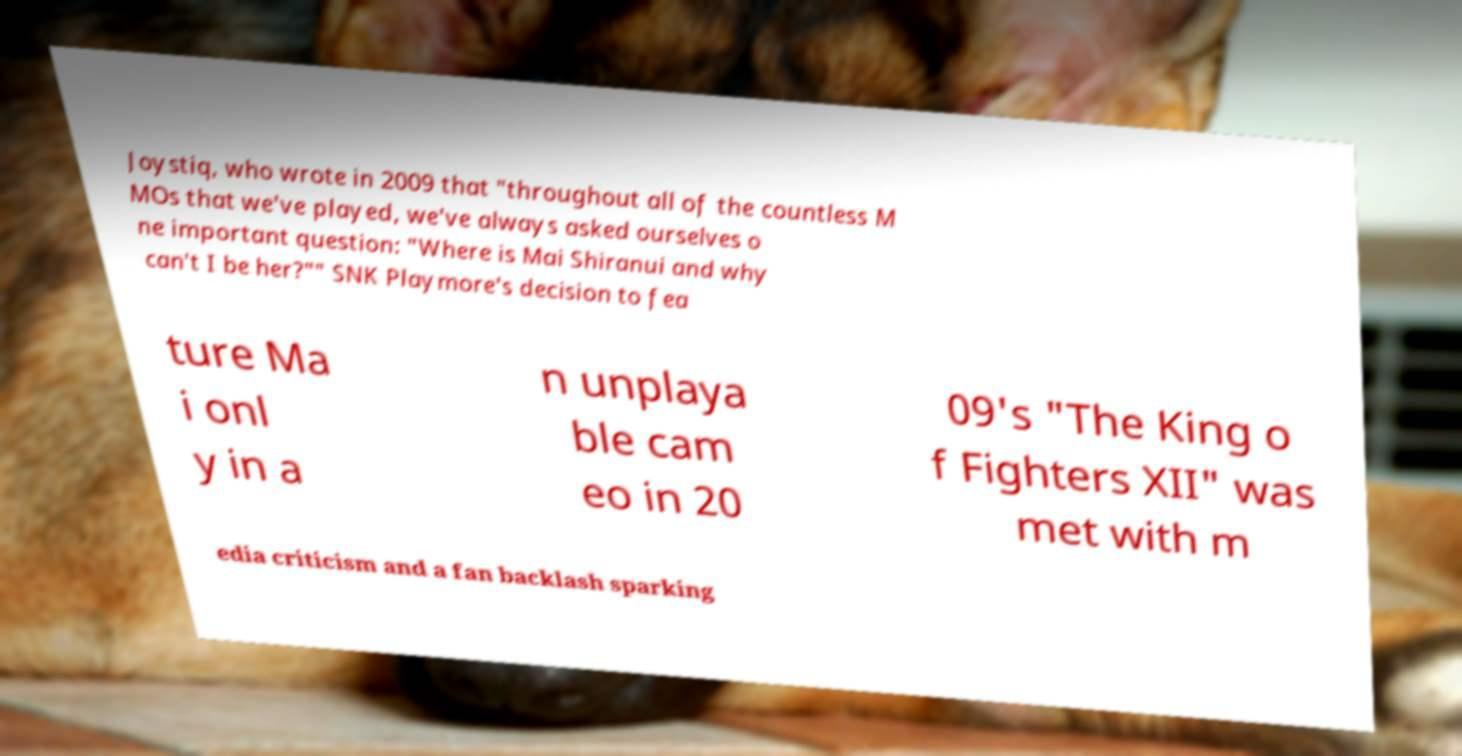For documentation purposes, I need the text within this image transcribed. Could you provide that? Joystiq, who wrote in 2009 that "throughout all of the countless M MOs that we've played, we've always asked ourselves o ne important question: "Where is Mai Shiranui and why can't I be her?"" SNK Playmore's decision to fea ture Ma i onl y in a n unplaya ble cam eo in 20 09's "The King o f Fighters XII" was met with m edia criticism and a fan backlash sparking 